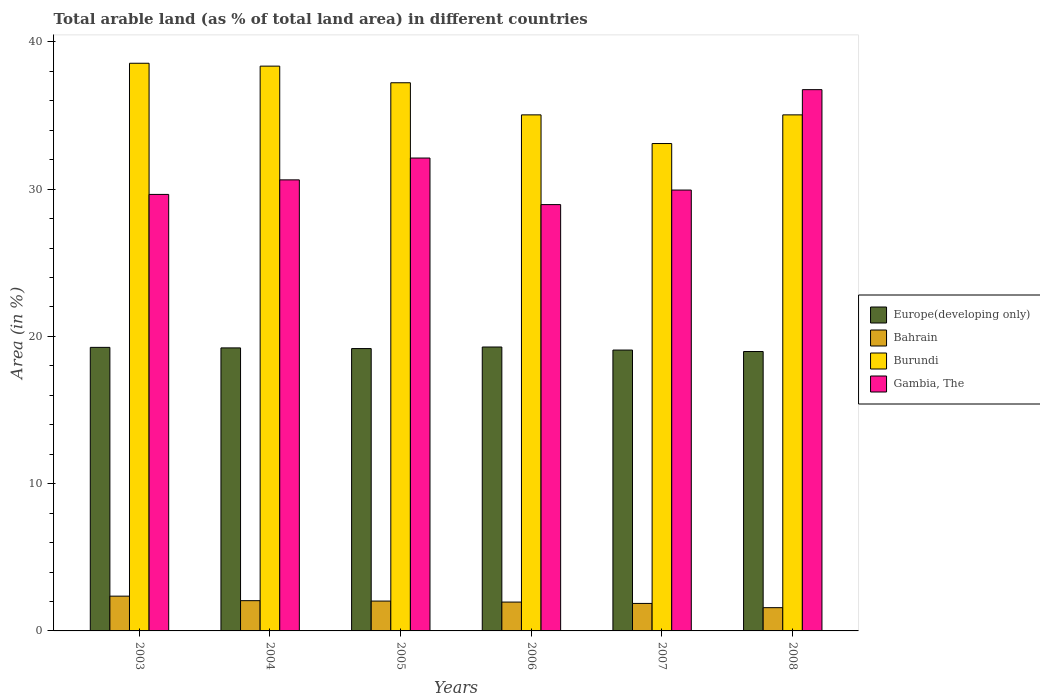Are the number of bars per tick equal to the number of legend labels?
Offer a terse response. Yes. Are the number of bars on each tick of the X-axis equal?
Offer a terse response. Yes. What is the label of the 5th group of bars from the left?
Your response must be concise. 2007. In how many cases, is the number of bars for a given year not equal to the number of legend labels?
Your answer should be compact. 0. What is the percentage of arable land in Europe(developing only) in 2005?
Offer a terse response. 19.18. Across all years, what is the maximum percentage of arable land in Gambia, The?
Offer a very short reply. 36.76. Across all years, what is the minimum percentage of arable land in Bahrain?
Give a very brief answer. 1.58. What is the total percentage of arable land in Gambia, The in the graph?
Make the answer very short. 188.04. What is the difference between the percentage of arable land in Gambia, The in 2003 and that in 2007?
Ensure brevity in your answer.  -0.3. What is the difference between the percentage of arable land in Bahrain in 2007 and the percentage of arable land in Europe(developing only) in 2004?
Offer a very short reply. -17.35. What is the average percentage of arable land in Gambia, The per year?
Your answer should be very brief. 31.34. In the year 2003, what is the difference between the percentage of arable land in Gambia, The and percentage of arable land in Burundi?
Provide a short and direct response. -8.91. What is the ratio of the percentage of arable land in Bahrain in 2004 to that in 2006?
Give a very brief answer. 1.05. Is the percentage of arable land in Bahrain in 2006 less than that in 2007?
Your response must be concise. No. What is the difference between the highest and the second highest percentage of arable land in Gambia, The?
Your answer should be compact. 4.64. What is the difference between the highest and the lowest percentage of arable land in Bahrain?
Your answer should be very brief. 0.78. In how many years, is the percentage of arable land in Europe(developing only) greater than the average percentage of arable land in Europe(developing only) taken over all years?
Offer a very short reply. 4. What does the 3rd bar from the left in 2008 represents?
Keep it short and to the point. Burundi. What does the 2nd bar from the right in 2008 represents?
Make the answer very short. Burundi. Is it the case that in every year, the sum of the percentage of arable land in Bahrain and percentage of arable land in Europe(developing only) is greater than the percentage of arable land in Gambia, The?
Your response must be concise. No. How many bars are there?
Ensure brevity in your answer.  24. Are all the bars in the graph horizontal?
Offer a terse response. No. What is the difference between two consecutive major ticks on the Y-axis?
Offer a terse response. 10. Does the graph contain any zero values?
Offer a terse response. No. Does the graph contain grids?
Offer a terse response. No. What is the title of the graph?
Provide a succinct answer. Total arable land (as % of total land area) in different countries. What is the label or title of the X-axis?
Your answer should be very brief. Years. What is the label or title of the Y-axis?
Your response must be concise. Area (in %). What is the Area (in %) in Europe(developing only) in 2003?
Your response must be concise. 19.26. What is the Area (in %) in Bahrain in 2003?
Your answer should be very brief. 2.36. What is the Area (in %) in Burundi in 2003?
Make the answer very short. 38.55. What is the Area (in %) in Gambia, The in 2003?
Your answer should be very brief. 29.64. What is the Area (in %) of Europe(developing only) in 2004?
Provide a short and direct response. 19.22. What is the Area (in %) of Bahrain in 2004?
Provide a short and direct response. 2.05. What is the Area (in %) of Burundi in 2004?
Offer a terse response. 38.36. What is the Area (in %) of Gambia, The in 2004?
Give a very brief answer. 30.63. What is the Area (in %) in Europe(developing only) in 2005?
Ensure brevity in your answer.  19.18. What is the Area (in %) of Bahrain in 2005?
Keep it short and to the point. 2.03. What is the Area (in %) of Burundi in 2005?
Provide a short and direct response. 37.23. What is the Area (in %) in Gambia, The in 2005?
Your answer should be very brief. 32.11. What is the Area (in %) of Europe(developing only) in 2006?
Your response must be concise. 19.28. What is the Area (in %) in Bahrain in 2006?
Give a very brief answer. 1.96. What is the Area (in %) in Burundi in 2006?
Give a very brief answer. 35.05. What is the Area (in %) of Gambia, The in 2006?
Your response must be concise. 28.95. What is the Area (in %) of Europe(developing only) in 2007?
Keep it short and to the point. 19.07. What is the Area (in %) of Bahrain in 2007?
Provide a short and direct response. 1.87. What is the Area (in %) in Burundi in 2007?
Your answer should be compact. 33.1. What is the Area (in %) in Gambia, The in 2007?
Keep it short and to the point. 29.94. What is the Area (in %) in Europe(developing only) in 2008?
Provide a succinct answer. 18.97. What is the Area (in %) of Bahrain in 2008?
Offer a very short reply. 1.58. What is the Area (in %) of Burundi in 2008?
Offer a terse response. 35.05. What is the Area (in %) in Gambia, The in 2008?
Make the answer very short. 36.76. Across all years, what is the maximum Area (in %) of Europe(developing only)?
Your answer should be very brief. 19.28. Across all years, what is the maximum Area (in %) of Bahrain?
Your response must be concise. 2.36. Across all years, what is the maximum Area (in %) in Burundi?
Offer a terse response. 38.55. Across all years, what is the maximum Area (in %) of Gambia, The?
Offer a very short reply. 36.76. Across all years, what is the minimum Area (in %) of Europe(developing only)?
Your answer should be compact. 18.97. Across all years, what is the minimum Area (in %) of Bahrain?
Your answer should be compact. 1.58. Across all years, what is the minimum Area (in %) of Burundi?
Give a very brief answer. 33.1. Across all years, what is the minimum Area (in %) of Gambia, The?
Your answer should be compact. 28.95. What is the total Area (in %) of Europe(developing only) in the graph?
Your answer should be compact. 114.98. What is the total Area (in %) in Bahrain in the graph?
Give a very brief answer. 11.85. What is the total Area (in %) in Burundi in the graph?
Offer a terse response. 217.33. What is the total Area (in %) of Gambia, The in the graph?
Your answer should be compact. 188.04. What is the difference between the Area (in %) of Europe(developing only) in 2003 and that in 2004?
Give a very brief answer. 0.04. What is the difference between the Area (in %) of Bahrain in 2003 and that in 2004?
Your answer should be very brief. 0.31. What is the difference between the Area (in %) in Burundi in 2003 and that in 2004?
Your answer should be compact. 0.19. What is the difference between the Area (in %) of Gambia, The in 2003 and that in 2004?
Your answer should be very brief. -0.99. What is the difference between the Area (in %) of Europe(developing only) in 2003 and that in 2005?
Your answer should be compact. 0.08. What is the difference between the Area (in %) of Bahrain in 2003 and that in 2005?
Your response must be concise. 0.33. What is the difference between the Area (in %) in Burundi in 2003 and that in 2005?
Give a very brief answer. 1.32. What is the difference between the Area (in %) in Gambia, The in 2003 and that in 2005?
Offer a terse response. -2.47. What is the difference between the Area (in %) in Europe(developing only) in 2003 and that in 2006?
Give a very brief answer. -0.02. What is the difference between the Area (in %) in Bahrain in 2003 and that in 2006?
Provide a short and direct response. 0.4. What is the difference between the Area (in %) in Burundi in 2003 and that in 2006?
Provide a succinct answer. 3.5. What is the difference between the Area (in %) in Gambia, The in 2003 and that in 2006?
Your answer should be very brief. 0.69. What is the difference between the Area (in %) of Europe(developing only) in 2003 and that in 2007?
Your answer should be compact. 0.18. What is the difference between the Area (in %) in Bahrain in 2003 and that in 2007?
Provide a succinct answer. 0.49. What is the difference between the Area (in %) in Burundi in 2003 and that in 2007?
Keep it short and to the point. 5.45. What is the difference between the Area (in %) of Gambia, The in 2003 and that in 2007?
Offer a very short reply. -0.3. What is the difference between the Area (in %) of Europe(developing only) in 2003 and that in 2008?
Your answer should be very brief. 0.28. What is the difference between the Area (in %) of Bahrain in 2003 and that in 2008?
Offer a terse response. 0.78. What is the difference between the Area (in %) of Burundi in 2003 and that in 2008?
Keep it short and to the point. 3.5. What is the difference between the Area (in %) of Gambia, The in 2003 and that in 2008?
Provide a succinct answer. -7.11. What is the difference between the Area (in %) of Europe(developing only) in 2004 and that in 2005?
Provide a short and direct response. 0.04. What is the difference between the Area (in %) of Bahrain in 2004 and that in 2005?
Your answer should be compact. 0.03. What is the difference between the Area (in %) of Burundi in 2004 and that in 2005?
Offer a terse response. 1.13. What is the difference between the Area (in %) of Gambia, The in 2004 and that in 2005?
Your answer should be compact. -1.48. What is the difference between the Area (in %) of Europe(developing only) in 2004 and that in 2006?
Ensure brevity in your answer.  -0.06. What is the difference between the Area (in %) of Bahrain in 2004 and that in 2006?
Give a very brief answer. 0.1. What is the difference between the Area (in %) in Burundi in 2004 and that in 2006?
Give a very brief answer. 3.31. What is the difference between the Area (in %) of Gambia, The in 2004 and that in 2006?
Provide a succinct answer. 1.68. What is the difference between the Area (in %) in Europe(developing only) in 2004 and that in 2007?
Provide a short and direct response. 0.15. What is the difference between the Area (in %) of Bahrain in 2004 and that in 2007?
Your answer should be compact. 0.19. What is the difference between the Area (in %) of Burundi in 2004 and that in 2007?
Keep it short and to the point. 5.26. What is the difference between the Area (in %) of Gambia, The in 2004 and that in 2007?
Make the answer very short. 0.69. What is the difference between the Area (in %) in Europe(developing only) in 2004 and that in 2008?
Provide a short and direct response. 0.25. What is the difference between the Area (in %) in Bahrain in 2004 and that in 2008?
Ensure brevity in your answer.  0.48. What is the difference between the Area (in %) in Burundi in 2004 and that in 2008?
Provide a succinct answer. 3.31. What is the difference between the Area (in %) of Gambia, The in 2004 and that in 2008?
Provide a succinct answer. -6.13. What is the difference between the Area (in %) in Europe(developing only) in 2005 and that in 2006?
Your answer should be very brief. -0.11. What is the difference between the Area (in %) of Bahrain in 2005 and that in 2006?
Your response must be concise. 0.07. What is the difference between the Area (in %) in Burundi in 2005 and that in 2006?
Your answer should be compact. 2.18. What is the difference between the Area (in %) of Gambia, The in 2005 and that in 2006?
Offer a very short reply. 3.16. What is the difference between the Area (in %) in Europe(developing only) in 2005 and that in 2007?
Ensure brevity in your answer.  0.1. What is the difference between the Area (in %) of Bahrain in 2005 and that in 2007?
Make the answer very short. 0.16. What is the difference between the Area (in %) of Burundi in 2005 and that in 2007?
Your answer should be very brief. 4.13. What is the difference between the Area (in %) of Gambia, The in 2005 and that in 2007?
Provide a succinct answer. 2.17. What is the difference between the Area (in %) of Europe(developing only) in 2005 and that in 2008?
Provide a succinct answer. 0.2. What is the difference between the Area (in %) of Bahrain in 2005 and that in 2008?
Give a very brief answer. 0.45. What is the difference between the Area (in %) in Burundi in 2005 and that in 2008?
Give a very brief answer. 2.18. What is the difference between the Area (in %) in Gambia, The in 2005 and that in 2008?
Your response must be concise. -4.64. What is the difference between the Area (in %) of Europe(developing only) in 2006 and that in 2007?
Provide a succinct answer. 0.21. What is the difference between the Area (in %) in Bahrain in 2006 and that in 2007?
Keep it short and to the point. 0.09. What is the difference between the Area (in %) in Burundi in 2006 and that in 2007?
Your response must be concise. 1.95. What is the difference between the Area (in %) in Gambia, The in 2006 and that in 2007?
Provide a short and direct response. -0.99. What is the difference between the Area (in %) in Europe(developing only) in 2006 and that in 2008?
Provide a short and direct response. 0.31. What is the difference between the Area (in %) of Bahrain in 2006 and that in 2008?
Your answer should be very brief. 0.38. What is the difference between the Area (in %) of Burundi in 2006 and that in 2008?
Ensure brevity in your answer.  0. What is the difference between the Area (in %) of Gambia, The in 2006 and that in 2008?
Provide a short and direct response. -7.81. What is the difference between the Area (in %) in Europe(developing only) in 2007 and that in 2008?
Your answer should be compact. 0.1. What is the difference between the Area (in %) of Bahrain in 2007 and that in 2008?
Provide a succinct answer. 0.29. What is the difference between the Area (in %) in Burundi in 2007 and that in 2008?
Your response must be concise. -1.95. What is the difference between the Area (in %) of Gambia, The in 2007 and that in 2008?
Your answer should be very brief. -6.82. What is the difference between the Area (in %) of Europe(developing only) in 2003 and the Area (in %) of Bahrain in 2004?
Keep it short and to the point. 17.2. What is the difference between the Area (in %) of Europe(developing only) in 2003 and the Area (in %) of Burundi in 2004?
Ensure brevity in your answer.  -19.1. What is the difference between the Area (in %) in Europe(developing only) in 2003 and the Area (in %) in Gambia, The in 2004?
Offer a terse response. -11.38. What is the difference between the Area (in %) of Bahrain in 2003 and the Area (in %) of Burundi in 2004?
Your answer should be compact. -36. What is the difference between the Area (in %) in Bahrain in 2003 and the Area (in %) in Gambia, The in 2004?
Give a very brief answer. -28.27. What is the difference between the Area (in %) in Burundi in 2003 and the Area (in %) in Gambia, The in 2004?
Your response must be concise. 7.92. What is the difference between the Area (in %) of Europe(developing only) in 2003 and the Area (in %) of Bahrain in 2005?
Provide a short and direct response. 17.23. What is the difference between the Area (in %) in Europe(developing only) in 2003 and the Area (in %) in Burundi in 2005?
Offer a very short reply. -17.97. What is the difference between the Area (in %) of Europe(developing only) in 2003 and the Area (in %) of Gambia, The in 2005?
Your answer should be compact. -12.86. What is the difference between the Area (in %) of Bahrain in 2003 and the Area (in %) of Burundi in 2005?
Offer a very short reply. -34.87. What is the difference between the Area (in %) in Bahrain in 2003 and the Area (in %) in Gambia, The in 2005?
Your answer should be very brief. -29.75. What is the difference between the Area (in %) in Burundi in 2003 and the Area (in %) in Gambia, The in 2005?
Your response must be concise. 6.44. What is the difference between the Area (in %) in Europe(developing only) in 2003 and the Area (in %) in Bahrain in 2006?
Your answer should be compact. 17.3. What is the difference between the Area (in %) in Europe(developing only) in 2003 and the Area (in %) in Burundi in 2006?
Offer a very short reply. -15.79. What is the difference between the Area (in %) in Europe(developing only) in 2003 and the Area (in %) in Gambia, The in 2006?
Offer a terse response. -9.7. What is the difference between the Area (in %) of Bahrain in 2003 and the Area (in %) of Burundi in 2006?
Your answer should be very brief. -32.69. What is the difference between the Area (in %) in Bahrain in 2003 and the Area (in %) in Gambia, The in 2006?
Your response must be concise. -26.59. What is the difference between the Area (in %) in Burundi in 2003 and the Area (in %) in Gambia, The in 2006?
Keep it short and to the point. 9.6. What is the difference between the Area (in %) in Europe(developing only) in 2003 and the Area (in %) in Bahrain in 2007?
Provide a succinct answer. 17.39. What is the difference between the Area (in %) of Europe(developing only) in 2003 and the Area (in %) of Burundi in 2007?
Your response must be concise. -13.84. What is the difference between the Area (in %) in Europe(developing only) in 2003 and the Area (in %) in Gambia, The in 2007?
Provide a succinct answer. -10.68. What is the difference between the Area (in %) in Bahrain in 2003 and the Area (in %) in Burundi in 2007?
Your response must be concise. -30.74. What is the difference between the Area (in %) of Bahrain in 2003 and the Area (in %) of Gambia, The in 2007?
Ensure brevity in your answer.  -27.58. What is the difference between the Area (in %) in Burundi in 2003 and the Area (in %) in Gambia, The in 2007?
Make the answer very short. 8.61. What is the difference between the Area (in %) of Europe(developing only) in 2003 and the Area (in %) of Bahrain in 2008?
Provide a short and direct response. 17.68. What is the difference between the Area (in %) in Europe(developing only) in 2003 and the Area (in %) in Burundi in 2008?
Your answer should be very brief. -15.79. What is the difference between the Area (in %) in Europe(developing only) in 2003 and the Area (in %) in Gambia, The in 2008?
Offer a terse response. -17.5. What is the difference between the Area (in %) of Bahrain in 2003 and the Area (in %) of Burundi in 2008?
Make the answer very short. -32.69. What is the difference between the Area (in %) in Bahrain in 2003 and the Area (in %) in Gambia, The in 2008?
Provide a succinct answer. -34.4. What is the difference between the Area (in %) in Burundi in 2003 and the Area (in %) in Gambia, The in 2008?
Make the answer very short. 1.79. What is the difference between the Area (in %) of Europe(developing only) in 2004 and the Area (in %) of Bahrain in 2005?
Give a very brief answer. 17.19. What is the difference between the Area (in %) in Europe(developing only) in 2004 and the Area (in %) in Burundi in 2005?
Make the answer very short. -18.01. What is the difference between the Area (in %) in Europe(developing only) in 2004 and the Area (in %) in Gambia, The in 2005?
Offer a terse response. -12.89. What is the difference between the Area (in %) of Bahrain in 2004 and the Area (in %) of Burundi in 2005?
Your response must be concise. -35.17. What is the difference between the Area (in %) in Bahrain in 2004 and the Area (in %) in Gambia, The in 2005?
Provide a succinct answer. -30.06. What is the difference between the Area (in %) in Burundi in 2004 and the Area (in %) in Gambia, The in 2005?
Make the answer very short. 6.24. What is the difference between the Area (in %) in Europe(developing only) in 2004 and the Area (in %) in Bahrain in 2006?
Provide a short and direct response. 17.26. What is the difference between the Area (in %) in Europe(developing only) in 2004 and the Area (in %) in Burundi in 2006?
Offer a terse response. -15.83. What is the difference between the Area (in %) in Europe(developing only) in 2004 and the Area (in %) in Gambia, The in 2006?
Give a very brief answer. -9.73. What is the difference between the Area (in %) in Bahrain in 2004 and the Area (in %) in Burundi in 2006?
Offer a terse response. -32.99. What is the difference between the Area (in %) in Bahrain in 2004 and the Area (in %) in Gambia, The in 2006?
Your response must be concise. -26.9. What is the difference between the Area (in %) of Burundi in 2004 and the Area (in %) of Gambia, The in 2006?
Provide a succinct answer. 9.4. What is the difference between the Area (in %) of Europe(developing only) in 2004 and the Area (in %) of Bahrain in 2007?
Offer a terse response. 17.35. What is the difference between the Area (in %) of Europe(developing only) in 2004 and the Area (in %) of Burundi in 2007?
Make the answer very short. -13.88. What is the difference between the Area (in %) of Europe(developing only) in 2004 and the Area (in %) of Gambia, The in 2007?
Keep it short and to the point. -10.72. What is the difference between the Area (in %) of Bahrain in 2004 and the Area (in %) of Burundi in 2007?
Your response must be concise. -31.04. What is the difference between the Area (in %) in Bahrain in 2004 and the Area (in %) in Gambia, The in 2007?
Make the answer very short. -27.89. What is the difference between the Area (in %) of Burundi in 2004 and the Area (in %) of Gambia, The in 2007?
Give a very brief answer. 8.42. What is the difference between the Area (in %) of Europe(developing only) in 2004 and the Area (in %) of Bahrain in 2008?
Provide a short and direct response. 17.64. What is the difference between the Area (in %) of Europe(developing only) in 2004 and the Area (in %) of Burundi in 2008?
Provide a short and direct response. -15.83. What is the difference between the Area (in %) in Europe(developing only) in 2004 and the Area (in %) in Gambia, The in 2008?
Provide a succinct answer. -17.54. What is the difference between the Area (in %) of Bahrain in 2004 and the Area (in %) of Burundi in 2008?
Ensure brevity in your answer.  -32.99. What is the difference between the Area (in %) of Bahrain in 2004 and the Area (in %) of Gambia, The in 2008?
Offer a terse response. -34.7. What is the difference between the Area (in %) in Burundi in 2004 and the Area (in %) in Gambia, The in 2008?
Provide a short and direct response. 1.6. What is the difference between the Area (in %) of Europe(developing only) in 2005 and the Area (in %) of Bahrain in 2006?
Offer a very short reply. 17.22. What is the difference between the Area (in %) of Europe(developing only) in 2005 and the Area (in %) of Burundi in 2006?
Provide a short and direct response. -15.87. What is the difference between the Area (in %) in Europe(developing only) in 2005 and the Area (in %) in Gambia, The in 2006?
Keep it short and to the point. -9.78. What is the difference between the Area (in %) in Bahrain in 2005 and the Area (in %) in Burundi in 2006?
Provide a short and direct response. -33.02. What is the difference between the Area (in %) in Bahrain in 2005 and the Area (in %) in Gambia, The in 2006?
Provide a succinct answer. -26.93. What is the difference between the Area (in %) of Burundi in 2005 and the Area (in %) of Gambia, The in 2006?
Your answer should be compact. 8.27. What is the difference between the Area (in %) of Europe(developing only) in 2005 and the Area (in %) of Bahrain in 2007?
Keep it short and to the point. 17.31. What is the difference between the Area (in %) of Europe(developing only) in 2005 and the Area (in %) of Burundi in 2007?
Provide a short and direct response. -13.92. What is the difference between the Area (in %) in Europe(developing only) in 2005 and the Area (in %) in Gambia, The in 2007?
Provide a short and direct response. -10.77. What is the difference between the Area (in %) in Bahrain in 2005 and the Area (in %) in Burundi in 2007?
Provide a short and direct response. -31.07. What is the difference between the Area (in %) in Bahrain in 2005 and the Area (in %) in Gambia, The in 2007?
Make the answer very short. -27.91. What is the difference between the Area (in %) in Burundi in 2005 and the Area (in %) in Gambia, The in 2007?
Your response must be concise. 7.29. What is the difference between the Area (in %) in Europe(developing only) in 2005 and the Area (in %) in Bahrain in 2008?
Ensure brevity in your answer.  17.6. What is the difference between the Area (in %) of Europe(developing only) in 2005 and the Area (in %) of Burundi in 2008?
Keep it short and to the point. -15.87. What is the difference between the Area (in %) in Europe(developing only) in 2005 and the Area (in %) in Gambia, The in 2008?
Give a very brief answer. -17.58. What is the difference between the Area (in %) in Bahrain in 2005 and the Area (in %) in Burundi in 2008?
Make the answer very short. -33.02. What is the difference between the Area (in %) in Bahrain in 2005 and the Area (in %) in Gambia, The in 2008?
Provide a short and direct response. -34.73. What is the difference between the Area (in %) of Burundi in 2005 and the Area (in %) of Gambia, The in 2008?
Your answer should be very brief. 0.47. What is the difference between the Area (in %) in Europe(developing only) in 2006 and the Area (in %) in Bahrain in 2007?
Your answer should be compact. 17.41. What is the difference between the Area (in %) of Europe(developing only) in 2006 and the Area (in %) of Burundi in 2007?
Your response must be concise. -13.82. What is the difference between the Area (in %) in Europe(developing only) in 2006 and the Area (in %) in Gambia, The in 2007?
Provide a succinct answer. -10.66. What is the difference between the Area (in %) in Bahrain in 2006 and the Area (in %) in Burundi in 2007?
Provide a short and direct response. -31.14. What is the difference between the Area (in %) of Bahrain in 2006 and the Area (in %) of Gambia, The in 2007?
Your response must be concise. -27.98. What is the difference between the Area (in %) in Burundi in 2006 and the Area (in %) in Gambia, The in 2007?
Ensure brevity in your answer.  5.11. What is the difference between the Area (in %) in Europe(developing only) in 2006 and the Area (in %) in Bahrain in 2008?
Make the answer very short. 17.7. What is the difference between the Area (in %) in Europe(developing only) in 2006 and the Area (in %) in Burundi in 2008?
Offer a terse response. -15.77. What is the difference between the Area (in %) in Europe(developing only) in 2006 and the Area (in %) in Gambia, The in 2008?
Offer a terse response. -17.48. What is the difference between the Area (in %) of Bahrain in 2006 and the Area (in %) of Burundi in 2008?
Make the answer very short. -33.09. What is the difference between the Area (in %) of Bahrain in 2006 and the Area (in %) of Gambia, The in 2008?
Give a very brief answer. -34.8. What is the difference between the Area (in %) in Burundi in 2006 and the Area (in %) in Gambia, The in 2008?
Keep it short and to the point. -1.71. What is the difference between the Area (in %) in Europe(developing only) in 2007 and the Area (in %) in Bahrain in 2008?
Your answer should be compact. 17.5. What is the difference between the Area (in %) in Europe(developing only) in 2007 and the Area (in %) in Burundi in 2008?
Keep it short and to the point. -15.97. What is the difference between the Area (in %) in Europe(developing only) in 2007 and the Area (in %) in Gambia, The in 2008?
Offer a terse response. -17.68. What is the difference between the Area (in %) in Bahrain in 2007 and the Area (in %) in Burundi in 2008?
Your response must be concise. -33.18. What is the difference between the Area (in %) of Bahrain in 2007 and the Area (in %) of Gambia, The in 2008?
Your response must be concise. -34.89. What is the difference between the Area (in %) of Burundi in 2007 and the Area (in %) of Gambia, The in 2008?
Offer a very short reply. -3.66. What is the average Area (in %) in Europe(developing only) per year?
Provide a succinct answer. 19.16. What is the average Area (in %) of Bahrain per year?
Give a very brief answer. 1.97. What is the average Area (in %) in Burundi per year?
Your answer should be very brief. 36.22. What is the average Area (in %) in Gambia, The per year?
Offer a terse response. 31.34. In the year 2003, what is the difference between the Area (in %) in Europe(developing only) and Area (in %) in Bahrain?
Provide a succinct answer. 16.9. In the year 2003, what is the difference between the Area (in %) of Europe(developing only) and Area (in %) of Burundi?
Your answer should be very brief. -19.29. In the year 2003, what is the difference between the Area (in %) in Europe(developing only) and Area (in %) in Gambia, The?
Offer a terse response. -10.39. In the year 2003, what is the difference between the Area (in %) in Bahrain and Area (in %) in Burundi?
Provide a succinct answer. -36.19. In the year 2003, what is the difference between the Area (in %) in Bahrain and Area (in %) in Gambia, The?
Make the answer very short. -27.28. In the year 2003, what is the difference between the Area (in %) of Burundi and Area (in %) of Gambia, The?
Make the answer very short. 8.91. In the year 2004, what is the difference between the Area (in %) of Europe(developing only) and Area (in %) of Bahrain?
Offer a very short reply. 17.17. In the year 2004, what is the difference between the Area (in %) in Europe(developing only) and Area (in %) in Burundi?
Your response must be concise. -19.14. In the year 2004, what is the difference between the Area (in %) in Europe(developing only) and Area (in %) in Gambia, The?
Make the answer very short. -11.41. In the year 2004, what is the difference between the Area (in %) of Bahrain and Area (in %) of Burundi?
Provide a short and direct response. -36.3. In the year 2004, what is the difference between the Area (in %) in Bahrain and Area (in %) in Gambia, The?
Offer a terse response. -28.58. In the year 2004, what is the difference between the Area (in %) of Burundi and Area (in %) of Gambia, The?
Provide a short and direct response. 7.72. In the year 2005, what is the difference between the Area (in %) in Europe(developing only) and Area (in %) in Bahrain?
Ensure brevity in your answer.  17.15. In the year 2005, what is the difference between the Area (in %) of Europe(developing only) and Area (in %) of Burundi?
Provide a short and direct response. -18.05. In the year 2005, what is the difference between the Area (in %) of Europe(developing only) and Area (in %) of Gambia, The?
Your answer should be very brief. -12.94. In the year 2005, what is the difference between the Area (in %) in Bahrain and Area (in %) in Burundi?
Provide a succinct answer. -35.2. In the year 2005, what is the difference between the Area (in %) of Bahrain and Area (in %) of Gambia, The?
Make the answer very short. -30.09. In the year 2005, what is the difference between the Area (in %) of Burundi and Area (in %) of Gambia, The?
Ensure brevity in your answer.  5.11. In the year 2006, what is the difference between the Area (in %) in Europe(developing only) and Area (in %) in Bahrain?
Offer a very short reply. 17.32. In the year 2006, what is the difference between the Area (in %) of Europe(developing only) and Area (in %) of Burundi?
Make the answer very short. -15.77. In the year 2006, what is the difference between the Area (in %) in Europe(developing only) and Area (in %) in Gambia, The?
Give a very brief answer. -9.67. In the year 2006, what is the difference between the Area (in %) of Bahrain and Area (in %) of Burundi?
Offer a very short reply. -33.09. In the year 2006, what is the difference between the Area (in %) in Bahrain and Area (in %) in Gambia, The?
Keep it short and to the point. -26.99. In the year 2006, what is the difference between the Area (in %) of Burundi and Area (in %) of Gambia, The?
Ensure brevity in your answer.  6.09. In the year 2007, what is the difference between the Area (in %) of Europe(developing only) and Area (in %) of Bahrain?
Your answer should be very brief. 17.21. In the year 2007, what is the difference between the Area (in %) of Europe(developing only) and Area (in %) of Burundi?
Provide a succinct answer. -14.03. In the year 2007, what is the difference between the Area (in %) in Europe(developing only) and Area (in %) in Gambia, The?
Your answer should be compact. -10.87. In the year 2007, what is the difference between the Area (in %) in Bahrain and Area (in %) in Burundi?
Your response must be concise. -31.23. In the year 2007, what is the difference between the Area (in %) in Bahrain and Area (in %) in Gambia, The?
Offer a very short reply. -28.07. In the year 2007, what is the difference between the Area (in %) of Burundi and Area (in %) of Gambia, The?
Give a very brief answer. 3.16. In the year 2008, what is the difference between the Area (in %) of Europe(developing only) and Area (in %) of Bahrain?
Offer a very short reply. 17.4. In the year 2008, what is the difference between the Area (in %) of Europe(developing only) and Area (in %) of Burundi?
Give a very brief answer. -16.07. In the year 2008, what is the difference between the Area (in %) of Europe(developing only) and Area (in %) of Gambia, The?
Make the answer very short. -17.78. In the year 2008, what is the difference between the Area (in %) in Bahrain and Area (in %) in Burundi?
Ensure brevity in your answer.  -33.47. In the year 2008, what is the difference between the Area (in %) of Bahrain and Area (in %) of Gambia, The?
Make the answer very short. -35.18. In the year 2008, what is the difference between the Area (in %) in Burundi and Area (in %) in Gambia, The?
Offer a terse response. -1.71. What is the ratio of the Area (in %) in Bahrain in 2003 to that in 2004?
Provide a succinct answer. 1.15. What is the ratio of the Area (in %) of Burundi in 2003 to that in 2004?
Give a very brief answer. 1.01. What is the ratio of the Area (in %) in Gambia, The in 2003 to that in 2004?
Your answer should be very brief. 0.97. What is the ratio of the Area (in %) of Bahrain in 2003 to that in 2005?
Ensure brevity in your answer.  1.16. What is the ratio of the Area (in %) in Burundi in 2003 to that in 2005?
Provide a short and direct response. 1.04. What is the ratio of the Area (in %) of Bahrain in 2003 to that in 2006?
Ensure brevity in your answer.  1.21. What is the ratio of the Area (in %) of Gambia, The in 2003 to that in 2006?
Provide a succinct answer. 1.02. What is the ratio of the Area (in %) of Europe(developing only) in 2003 to that in 2007?
Offer a terse response. 1.01. What is the ratio of the Area (in %) in Bahrain in 2003 to that in 2007?
Provide a succinct answer. 1.26. What is the ratio of the Area (in %) in Burundi in 2003 to that in 2007?
Offer a very short reply. 1.16. What is the ratio of the Area (in %) of Gambia, The in 2003 to that in 2007?
Provide a short and direct response. 0.99. What is the ratio of the Area (in %) in Europe(developing only) in 2003 to that in 2008?
Offer a terse response. 1.01. What is the ratio of the Area (in %) in Bahrain in 2003 to that in 2008?
Provide a succinct answer. 1.5. What is the ratio of the Area (in %) of Gambia, The in 2003 to that in 2008?
Provide a succinct answer. 0.81. What is the ratio of the Area (in %) in Bahrain in 2004 to that in 2005?
Your response must be concise. 1.01. What is the ratio of the Area (in %) of Burundi in 2004 to that in 2005?
Your response must be concise. 1.03. What is the ratio of the Area (in %) in Gambia, The in 2004 to that in 2005?
Your response must be concise. 0.95. What is the ratio of the Area (in %) of Bahrain in 2004 to that in 2006?
Provide a succinct answer. 1.05. What is the ratio of the Area (in %) of Burundi in 2004 to that in 2006?
Give a very brief answer. 1.09. What is the ratio of the Area (in %) of Gambia, The in 2004 to that in 2006?
Keep it short and to the point. 1.06. What is the ratio of the Area (in %) in Europe(developing only) in 2004 to that in 2007?
Offer a terse response. 1.01. What is the ratio of the Area (in %) in Bahrain in 2004 to that in 2007?
Offer a very short reply. 1.1. What is the ratio of the Area (in %) in Burundi in 2004 to that in 2007?
Offer a very short reply. 1.16. What is the ratio of the Area (in %) of Gambia, The in 2004 to that in 2007?
Give a very brief answer. 1.02. What is the ratio of the Area (in %) in Europe(developing only) in 2004 to that in 2008?
Give a very brief answer. 1.01. What is the ratio of the Area (in %) of Bahrain in 2004 to that in 2008?
Your answer should be very brief. 1.3. What is the ratio of the Area (in %) of Burundi in 2004 to that in 2008?
Your response must be concise. 1.09. What is the ratio of the Area (in %) in Gambia, The in 2004 to that in 2008?
Offer a terse response. 0.83. What is the ratio of the Area (in %) in Europe(developing only) in 2005 to that in 2006?
Your response must be concise. 0.99. What is the ratio of the Area (in %) in Bahrain in 2005 to that in 2006?
Your answer should be compact. 1.03. What is the ratio of the Area (in %) in Burundi in 2005 to that in 2006?
Provide a succinct answer. 1.06. What is the ratio of the Area (in %) of Gambia, The in 2005 to that in 2006?
Provide a short and direct response. 1.11. What is the ratio of the Area (in %) in Europe(developing only) in 2005 to that in 2007?
Offer a terse response. 1.01. What is the ratio of the Area (in %) in Bahrain in 2005 to that in 2007?
Your answer should be very brief. 1.09. What is the ratio of the Area (in %) in Burundi in 2005 to that in 2007?
Keep it short and to the point. 1.12. What is the ratio of the Area (in %) in Gambia, The in 2005 to that in 2007?
Give a very brief answer. 1.07. What is the ratio of the Area (in %) in Europe(developing only) in 2005 to that in 2008?
Give a very brief answer. 1.01. What is the ratio of the Area (in %) in Bahrain in 2005 to that in 2008?
Provide a short and direct response. 1.28. What is the ratio of the Area (in %) of Burundi in 2005 to that in 2008?
Your answer should be compact. 1.06. What is the ratio of the Area (in %) in Gambia, The in 2005 to that in 2008?
Provide a short and direct response. 0.87. What is the ratio of the Area (in %) of Europe(developing only) in 2006 to that in 2007?
Provide a short and direct response. 1.01. What is the ratio of the Area (in %) in Bahrain in 2006 to that in 2007?
Keep it short and to the point. 1.05. What is the ratio of the Area (in %) of Burundi in 2006 to that in 2007?
Offer a terse response. 1.06. What is the ratio of the Area (in %) of Europe(developing only) in 2006 to that in 2008?
Keep it short and to the point. 1.02. What is the ratio of the Area (in %) of Bahrain in 2006 to that in 2008?
Offer a terse response. 1.24. What is the ratio of the Area (in %) of Burundi in 2006 to that in 2008?
Your answer should be compact. 1. What is the ratio of the Area (in %) of Gambia, The in 2006 to that in 2008?
Your answer should be compact. 0.79. What is the ratio of the Area (in %) of Bahrain in 2007 to that in 2008?
Keep it short and to the point. 1.18. What is the ratio of the Area (in %) in Gambia, The in 2007 to that in 2008?
Ensure brevity in your answer.  0.81. What is the difference between the highest and the second highest Area (in %) of Europe(developing only)?
Provide a short and direct response. 0.02. What is the difference between the highest and the second highest Area (in %) in Bahrain?
Ensure brevity in your answer.  0.31. What is the difference between the highest and the second highest Area (in %) in Burundi?
Provide a succinct answer. 0.19. What is the difference between the highest and the second highest Area (in %) of Gambia, The?
Provide a short and direct response. 4.64. What is the difference between the highest and the lowest Area (in %) of Europe(developing only)?
Your answer should be compact. 0.31. What is the difference between the highest and the lowest Area (in %) of Bahrain?
Your response must be concise. 0.78. What is the difference between the highest and the lowest Area (in %) in Burundi?
Give a very brief answer. 5.45. What is the difference between the highest and the lowest Area (in %) of Gambia, The?
Keep it short and to the point. 7.81. 